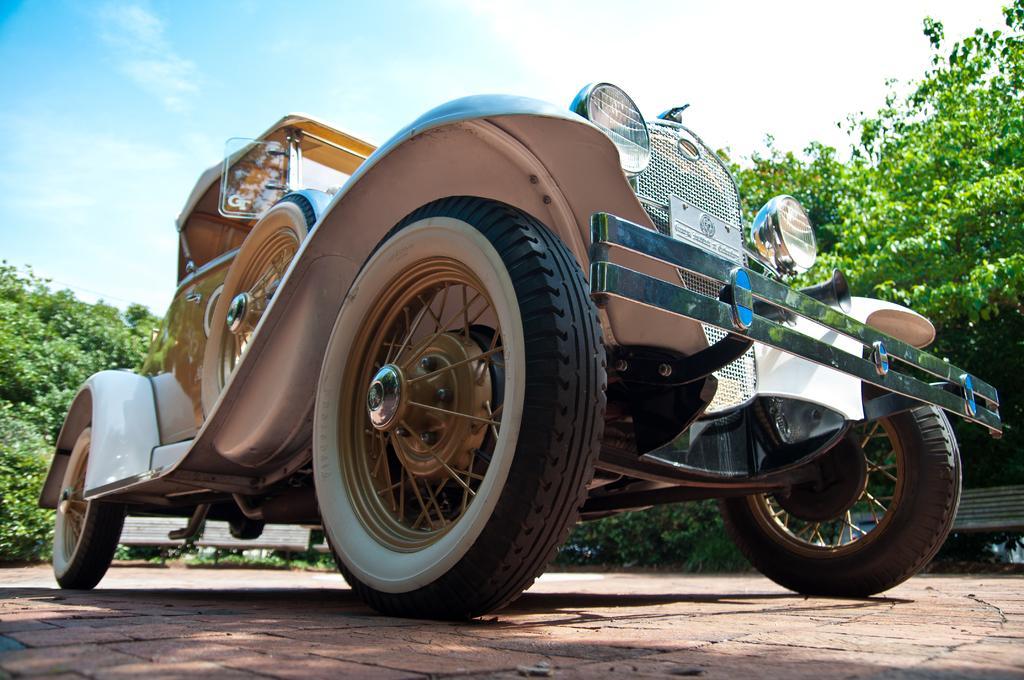Can you describe this image briefly? In this image, we can see a vehicle. We can see the ground and some benches. There are a few trees. We can also see the sky with clouds. 